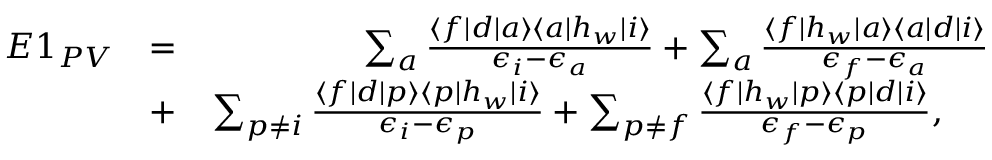<formula> <loc_0><loc_0><loc_500><loc_500>\begin{array} { r l r } { E 1 _ { P V } } & { = } & { \sum _ { a } \frac { \langle f | d | a \rangle \langle a | h _ { w } | i \rangle } { \epsilon _ { i } - \epsilon _ { a } } + \sum _ { a } \frac { \langle f | h _ { w } | a \rangle \langle a | d | i \rangle } { \epsilon _ { f } - \epsilon _ { a } } } \\ & { + } & { \sum _ { p \ne i } \frac { \langle f | d | p \rangle \langle p | h _ { w } | i \rangle } { \epsilon _ { i } - \epsilon _ { p } } + \sum _ { p \ne f } \frac { \langle f | h _ { w } | p \rangle \langle p | d | i \rangle } { \epsilon _ { f } - \epsilon _ { p } } , \quad } \end{array}</formula> 